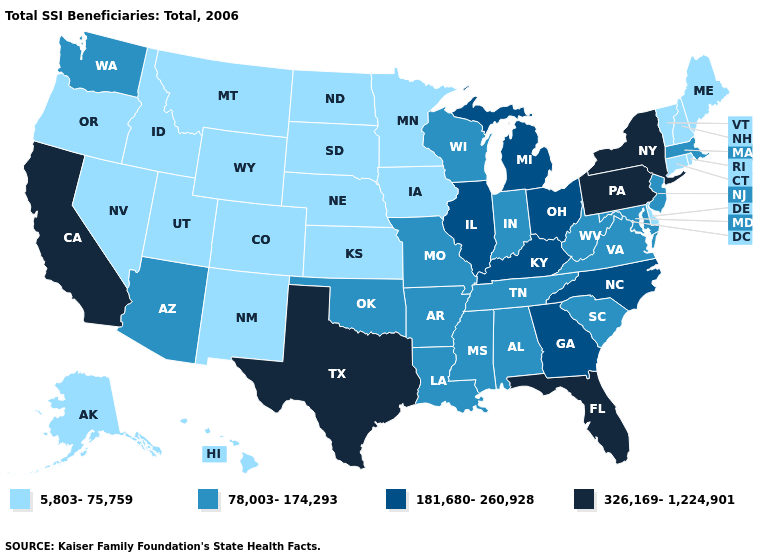Does Oklahoma have the same value as Missouri?
Write a very short answer. Yes. Does Iowa have the highest value in the MidWest?
Write a very short answer. No. Name the states that have a value in the range 78,003-174,293?
Keep it brief. Alabama, Arizona, Arkansas, Indiana, Louisiana, Maryland, Massachusetts, Mississippi, Missouri, New Jersey, Oklahoma, South Carolina, Tennessee, Virginia, Washington, West Virginia, Wisconsin. What is the value of Nebraska?
Answer briefly. 5,803-75,759. Among the states that border West Virginia , does Pennsylvania have the highest value?
Answer briefly. Yes. What is the value of New Hampshire?
Quick response, please. 5,803-75,759. Name the states that have a value in the range 181,680-260,928?
Keep it brief. Georgia, Illinois, Kentucky, Michigan, North Carolina, Ohio. Among the states that border Missouri , which have the highest value?
Write a very short answer. Illinois, Kentucky. Does the map have missing data?
Give a very brief answer. No. Name the states that have a value in the range 78,003-174,293?
Keep it brief. Alabama, Arizona, Arkansas, Indiana, Louisiana, Maryland, Massachusetts, Mississippi, Missouri, New Jersey, Oklahoma, South Carolina, Tennessee, Virginia, Washington, West Virginia, Wisconsin. What is the value of Florida?
Concise answer only. 326,169-1,224,901. Does the first symbol in the legend represent the smallest category?
Write a very short answer. Yes. Name the states that have a value in the range 326,169-1,224,901?
Be succinct. California, Florida, New York, Pennsylvania, Texas. Name the states that have a value in the range 326,169-1,224,901?
Give a very brief answer. California, Florida, New York, Pennsylvania, Texas. Is the legend a continuous bar?
Keep it brief. No. 